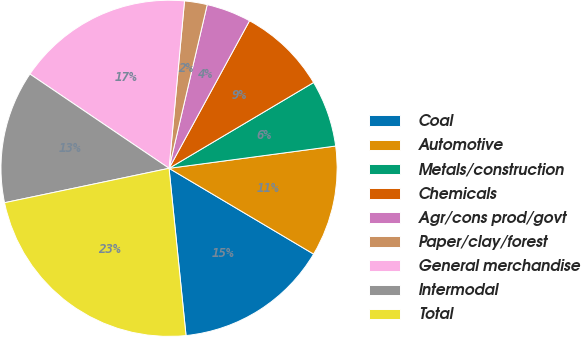Convert chart. <chart><loc_0><loc_0><loc_500><loc_500><pie_chart><fcel>Coal<fcel>Automotive<fcel>Metals/construction<fcel>Chemicals<fcel>Agr/cons prod/govt<fcel>Paper/clay/forest<fcel>General merchandise<fcel>Intermodal<fcel>Total<nl><fcel>14.87%<fcel>10.64%<fcel>6.41%<fcel>8.53%<fcel>4.3%<fcel>2.18%<fcel>16.99%<fcel>12.76%<fcel>23.33%<nl></chart> 